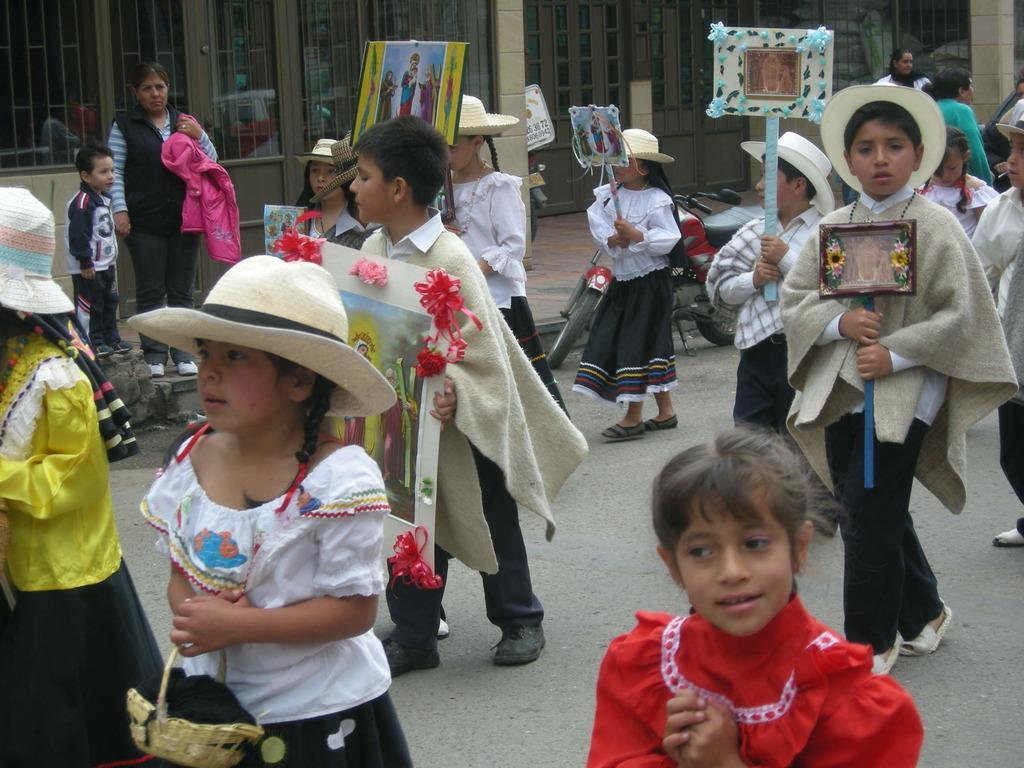Please provide a concise description of this image. In this picture there are children in the image, by holding posters in their hands and there is a building at the top side of the image. 